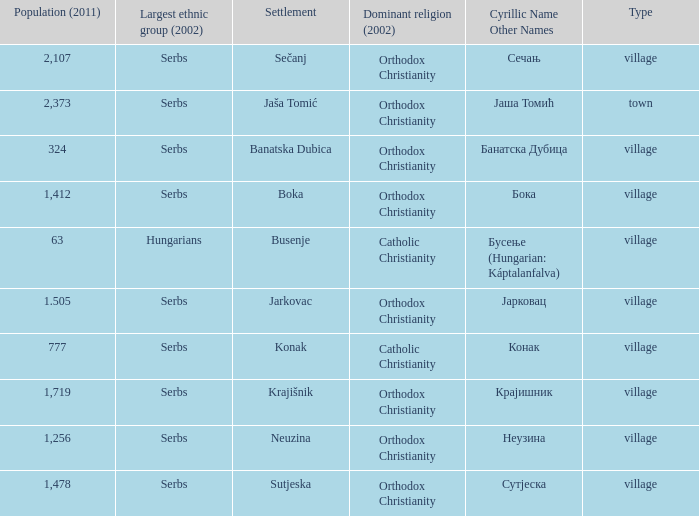What town has the population of 777? Конак. 